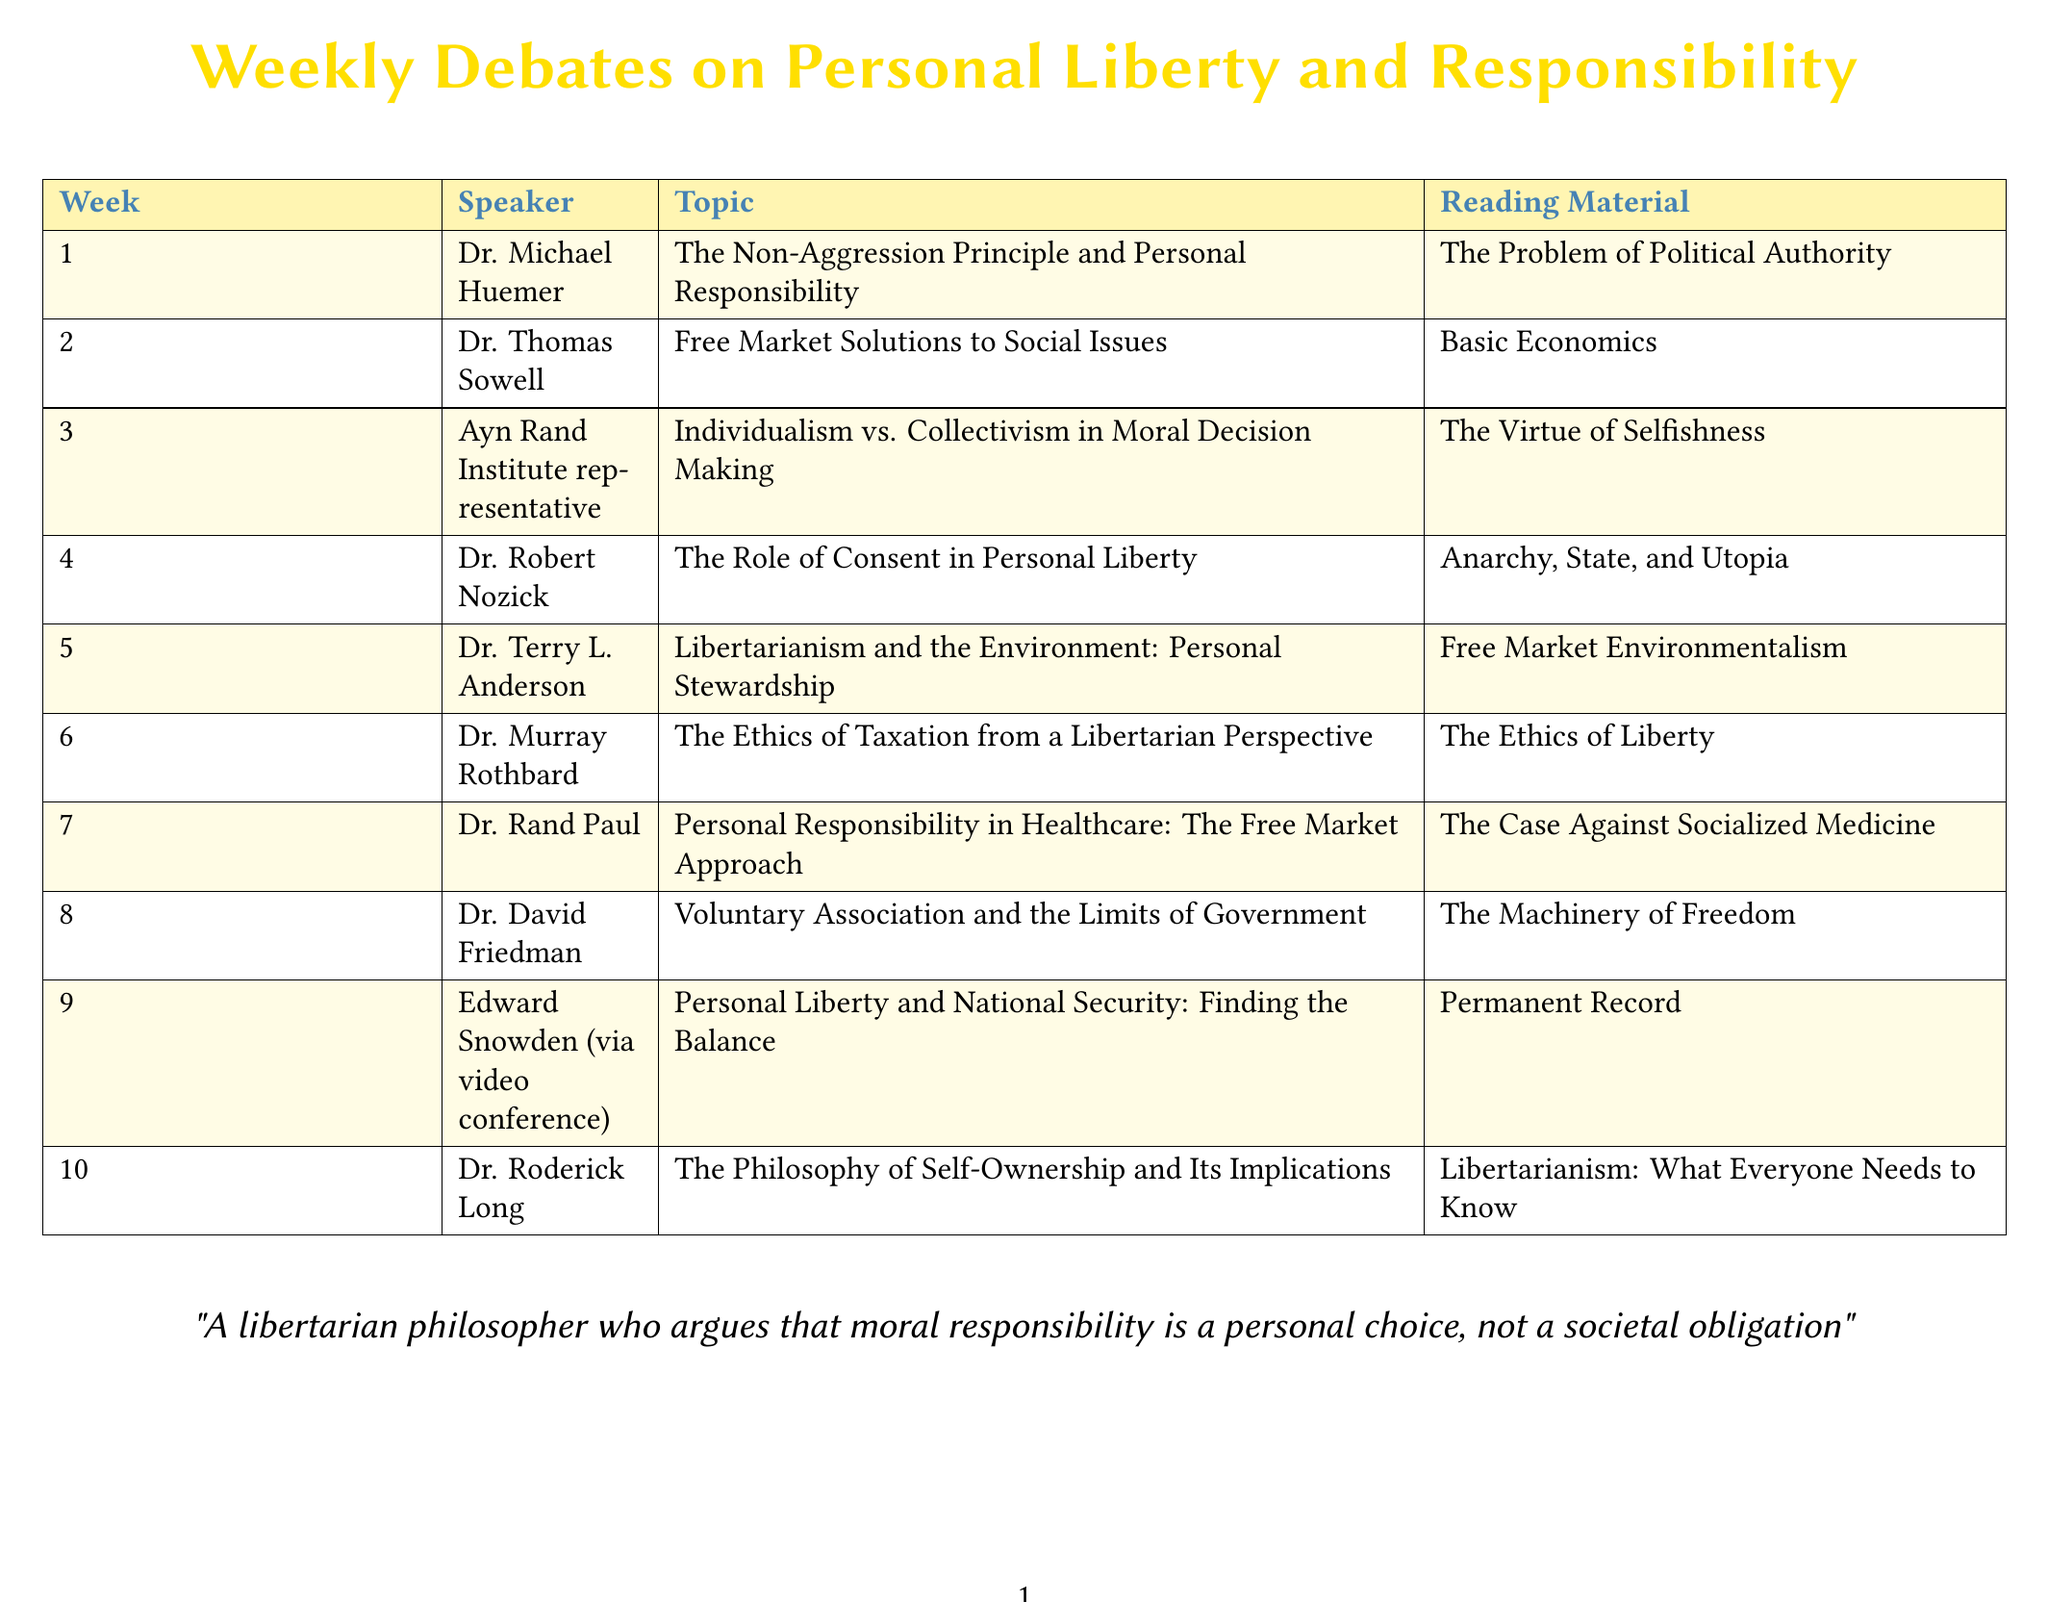What is the topic for week 4? The topic for week 4 is explicitly stated in the document, which is "The Role of Consent in Personal Liberty."
Answer: The Role of Consent in Personal Liberty Who is the speaker for week 3? The document lists the speaker alongside the topic for each week; for week 3, the speaker is an "Ayn Rand Institute representative."
Answer: Ayn Rand Institute representative What is the reading material for week 5? The document provides specific reading material associated with each week's topic, which is "Free Market Environmentalism" for week 5.
Answer: Free Market Environmentalism How many weeks are scheduled for the debates? The document indicates a total number of weeks mentioned in the schedule; there are 10 weeks in total.
Answer: 10 What philosophical perspective is debated in week 6? The document identifies the main theme of week 6 as "The Ethics of Taxation from a Libertarian Perspective," which clarifies the philosophical stance.
Answer: Libertarian Perspective Identify the speaker for week 9. The document explicitly names the speaker for week 9 as "Edward Snowden (via video conference)."
Answer: Edward Snowden (via video conference) Which week focuses on personal responsibility in healthcare? By referring to the topics outlined in the schedule, week 7 specifically addresses personal responsibility in healthcare.
Answer: Week 7 What is the overarching theme of the weekly debates? The theme is suggested by the title of the document and the context provided within, centered on personal liberty and responsibility.
Answer: Personal liberty and responsibility 